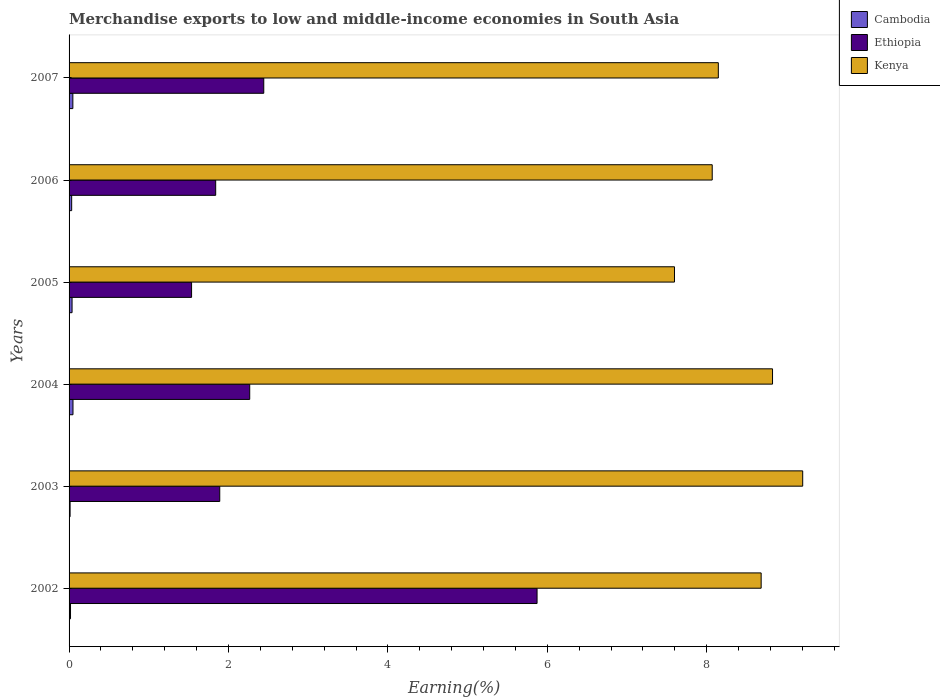How many different coloured bars are there?
Offer a terse response. 3. How many groups of bars are there?
Provide a short and direct response. 6. Are the number of bars per tick equal to the number of legend labels?
Provide a succinct answer. Yes. How many bars are there on the 5th tick from the top?
Keep it short and to the point. 3. What is the percentage of amount earned from merchandise exports in Ethiopia in 2004?
Your answer should be compact. 2.27. Across all years, what is the maximum percentage of amount earned from merchandise exports in Kenya?
Give a very brief answer. 9.2. Across all years, what is the minimum percentage of amount earned from merchandise exports in Ethiopia?
Give a very brief answer. 1.54. In which year was the percentage of amount earned from merchandise exports in Kenya maximum?
Make the answer very short. 2003. In which year was the percentage of amount earned from merchandise exports in Cambodia minimum?
Provide a succinct answer. 2003. What is the total percentage of amount earned from merchandise exports in Cambodia in the graph?
Keep it short and to the point. 0.2. What is the difference between the percentage of amount earned from merchandise exports in Kenya in 2002 and that in 2003?
Provide a short and direct response. -0.52. What is the difference between the percentage of amount earned from merchandise exports in Kenya in 2004 and the percentage of amount earned from merchandise exports in Cambodia in 2007?
Provide a short and direct response. 8.78. What is the average percentage of amount earned from merchandise exports in Cambodia per year?
Your answer should be very brief. 0.03. In the year 2003, what is the difference between the percentage of amount earned from merchandise exports in Ethiopia and percentage of amount earned from merchandise exports in Cambodia?
Provide a succinct answer. 1.88. What is the ratio of the percentage of amount earned from merchandise exports in Kenya in 2006 to that in 2007?
Your answer should be very brief. 0.99. Is the percentage of amount earned from merchandise exports in Ethiopia in 2003 less than that in 2004?
Give a very brief answer. Yes. What is the difference between the highest and the second highest percentage of amount earned from merchandise exports in Kenya?
Your response must be concise. 0.38. What is the difference between the highest and the lowest percentage of amount earned from merchandise exports in Kenya?
Give a very brief answer. 1.61. In how many years, is the percentage of amount earned from merchandise exports in Kenya greater than the average percentage of amount earned from merchandise exports in Kenya taken over all years?
Offer a terse response. 3. Is the sum of the percentage of amount earned from merchandise exports in Ethiopia in 2005 and 2006 greater than the maximum percentage of amount earned from merchandise exports in Kenya across all years?
Offer a very short reply. No. What does the 1st bar from the top in 2004 represents?
Ensure brevity in your answer.  Kenya. What does the 3rd bar from the bottom in 2005 represents?
Your response must be concise. Kenya. What is the difference between two consecutive major ticks on the X-axis?
Give a very brief answer. 2. Does the graph contain any zero values?
Give a very brief answer. No. Where does the legend appear in the graph?
Provide a short and direct response. Top right. What is the title of the graph?
Your answer should be very brief. Merchandise exports to low and middle-income economies in South Asia. What is the label or title of the X-axis?
Keep it short and to the point. Earning(%). What is the Earning(%) in Cambodia in 2002?
Ensure brevity in your answer.  0.02. What is the Earning(%) of Ethiopia in 2002?
Your response must be concise. 5.87. What is the Earning(%) in Kenya in 2002?
Provide a short and direct response. 8.68. What is the Earning(%) in Cambodia in 2003?
Keep it short and to the point. 0.01. What is the Earning(%) in Ethiopia in 2003?
Make the answer very short. 1.89. What is the Earning(%) in Kenya in 2003?
Give a very brief answer. 9.2. What is the Earning(%) of Cambodia in 2004?
Ensure brevity in your answer.  0.05. What is the Earning(%) of Ethiopia in 2004?
Provide a succinct answer. 2.27. What is the Earning(%) in Kenya in 2004?
Give a very brief answer. 8.83. What is the Earning(%) in Cambodia in 2005?
Provide a short and direct response. 0.04. What is the Earning(%) in Ethiopia in 2005?
Your answer should be very brief. 1.54. What is the Earning(%) in Kenya in 2005?
Ensure brevity in your answer.  7.6. What is the Earning(%) of Cambodia in 2006?
Keep it short and to the point. 0.03. What is the Earning(%) of Ethiopia in 2006?
Ensure brevity in your answer.  1.84. What is the Earning(%) in Kenya in 2006?
Keep it short and to the point. 8.07. What is the Earning(%) of Cambodia in 2007?
Keep it short and to the point. 0.05. What is the Earning(%) in Ethiopia in 2007?
Give a very brief answer. 2.44. What is the Earning(%) in Kenya in 2007?
Your answer should be very brief. 8.15. Across all years, what is the maximum Earning(%) of Cambodia?
Your answer should be compact. 0.05. Across all years, what is the maximum Earning(%) in Ethiopia?
Offer a terse response. 5.87. Across all years, what is the maximum Earning(%) in Kenya?
Ensure brevity in your answer.  9.2. Across all years, what is the minimum Earning(%) of Cambodia?
Provide a short and direct response. 0.01. Across all years, what is the minimum Earning(%) in Ethiopia?
Your response must be concise. 1.54. Across all years, what is the minimum Earning(%) of Kenya?
Keep it short and to the point. 7.6. What is the total Earning(%) of Cambodia in the graph?
Ensure brevity in your answer.  0.2. What is the total Earning(%) of Ethiopia in the graph?
Offer a terse response. 15.85. What is the total Earning(%) in Kenya in the graph?
Your response must be concise. 50.52. What is the difference between the Earning(%) in Cambodia in 2002 and that in 2003?
Your response must be concise. 0.01. What is the difference between the Earning(%) of Ethiopia in 2002 and that in 2003?
Provide a short and direct response. 3.98. What is the difference between the Earning(%) of Kenya in 2002 and that in 2003?
Ensure brevity in your answer.  -0.52. What is the difference between the Earning(%) of Cambodia in 2002 and that in 2004?
Your answer should be compact. -0.03. What is the difference between the Earning(%) of Ethiopia in 2002 and that in 2004?
Your response must be concise. 3.6. What is the difference between the Earning(%) of Kenya in 2002 and that in 2004?
Provide a succinct answer. -0.14. What is the difference between the Earning(%) in Cambodia in 2002 and that in 2005?
Keep it short and to the point. -0.02. What is the difference between the Earning(%) in Ethiopia in 2002 and that in 2005?
Keep it short and to the point. 4.33. What is the difference between the Earning(%) in Kenya in 2002 and that in 2005?
Offer a terse response. 1.09. What is the difference between the Earning(%) in Cambodia in 2002 and that in 2006?
Provide a short and direct response. -0.01. What is the difference between the Earning(%) of Ethiopia in 2002 and that in 2006?
Give a very brief answer. 4.03. What is the difference between the Earning(%) in Kenya in 2002 and that in 2006?
Provide a short and direct response. 0.61. What is the difference between the Earning(%) of Cambodia in 2002 and that in 2007?
Make the answer very short. -0.03. What is the difference between the Earning(%) in Ethiopia in 2002 and that in 2007?
Make the answer very short. 3.43. What is the difference between the Earning(%) in Kenya in 2002 and that in 2007?
Provide a short and direct response. 0.54. What is the difference between the Earning(%) in Cambodia in 2003 and that in 2004?
Provide a succinct answer. -0.04. What is the difference between the Earning(%) in Ethiopia in 2003 and that in 2004?
Your response must be concise. -0.38. What is the difference between the Earning(%) in Kenya in 2003 and that in 2004?
Give a very brief answer. 0.38. What is the difference between the Earning(%) in Cambodia in 2003 and that in 2005?
Provide a succinct answer. -0.02. What is the difference between the Earning(%) of Ethiopia in 2003 and that in 2005?
Keep it short and to the point. 0.35. What is the difference between the Earning(%) of Kenya in 2003 and that in 2005?
Your answer should be compact. 1.61. What is the difference between the Earning(%) in Cambodia in 2003 and that in 2006?
Provide a short and direct response. -0.02. What is the difference between the Earning(%) in Ethiopia in 2003 and that in 2006?
Your answer should be compact. 0.05. What is the difference between the Earning(%) in Kenya in 2003 and that in 2006?
Provide a succinct answer. 1.14. What is the difference between the Earning(%) of Cambodia in 2003 and that in 2007?
Ensure brevity in your answer.  -0.03. What is the difference between the Earning(%) in Ethiopia in 2003 and that in 2007?
Offer a very short reply. -0.55. What is the difference between the Earning(%) of Kenya in 2003 and that in 2007?
Offer a terse response. 1.06. What is the difference between the Earning(%) of Cambodia in 2004 and that in 2005?
Offer a very short reply. 0.01. What is the difference between the Earning(%) of Ethiopia in 2004 and that in 2005?
Your response must be concise. 0.73. What is the difference between the Earning(%) of Kenya in 2004 and that in 2005?
Ensure brevity in your answer.  1.23. What is the difference between the Earning(%) of Cambodia in 2004 and that in 2006?
Your response must be concise. 0.02. What is the difference between the Earning(%) of Ethiopia in 2004 and that in 2006?
Give a very brief answer. 0.43. What is the difference between the Earning(%) in Kenya in 2004 and that in 2006?
Offer a terse response. 0.76. What is the difference between the Earning(%) of Cambodia in 2004 and that in 2007?
Ensure brevity in your answer.  0. What is the difference between the Earning(%) of Ethiopia in 2004 and that in 2007?
Offer a terse response. -0.18. What is the difference between the Earning(%) of Kenya in 2004 and that in 2007?
Your answer should be compact. 0.68. What is the difference between the Earning(%) of Cambodia in 2005 and that in 2006?
Your response must be concise. 0. What is the difference between the Earning(%) of Ethiopia in 2005 and that in 2006?
Your answer should be compact. -0.3. What is the difference between the Earning(%) in Kenya in 2005 and that in 2006?
Your response must be concise. -0.47. What is the difference between the Earning(%) in Cambodia in 2005 and that in 2007?
Your response must be concise. -0.01. What is the difference between the Earning(%) in Ethiopia in 2005 and that in 2007?
Give a very brief answer. -0.91. What is the difference between the Earning(%) of Kenya in 2005 and that in 2007?
Keep it short and to the point. -0.55. What is the difference between the Earning(%) in Cambodia in 2006 and that in 2007?
Keep it short and to the point. -0.01. What is the difference between the Earning(%) of Ethiopia in 2006 and that in 2007?
Your answer should be compact. -0.6. What is the difference between the Earning(%) in Kenya in 2006 and that in 2007?
Offer a very short reply. -0.08. What is the difference between the Earning(%) in Cambodia in 2002 and the Earning(%) in Ethiopia in 2003?
Your response must be concise. -1.87. What is the difference between the Earning(%) in Cambodia in 2002 and the Earning(%) in Kenya in 2003?
Your answer should be compact. -9.19. What is the difference between the Earning(%) of Ethiopia in 2002 and the Earning(%) of Kenya in 2003?
Your answer should be compact. -3.33. What is the difference between the Earning(%) in Cambodia in 2002 and the Earning(%) in Ethiopia in 2004?
Offer a very short reply. -2.25. What is the difference between the Earning(%) in Cambodia in 2002 and the Earning(%) in Kenya in 2004?
Your response must be concise. -8.81. What is the difference between the Earning(%) in Ethiopia in 2002 and the Earning(%) in Kenya in 2004?
Make the answer very short. -2.95. What is the difference between the Earning(%) in Cambodia in 2002 and the Earning(%) in Ethiopia in 2005?
Offer a terse response. -1.52. What is the difference between the Earning(%) of Cambodia in 2002 and the Earning(%) of Kenya in 2005?
Ensure brevity in your answer.  -7.58. What is the difference between the Earning(%) in Ethiopia in 2002 and the Earning(%) in Kenya in 2005?
Your answer should be very brief. -1.72. What is the difference between the Earning(%) in Cambodia in 2002 and the Earning(%) in Ethiopia in 2006?
Your answer should be very brief. -1.82. What is the difference between the Earning(%) of Cambodia in 2002 and the Earning(%) of Kenya in 2006?
Provide a succinct answer. -8.05. What is the difference between the Earning(%) of Ethiopia in 2002 and the Earning(%) of Kenya in 2006?
Provide a short and direct response. -2.2. What is the difference between the Earning(%) of Cambodia in 2002 and the Earning(%) of Ethiopia in 2007?
Your answer should be compact. -2.42. What is the difference between the Earning(%) in Cambodia in 2002 and the Earning(%) in Kenya in 2007?
Provide a succinct answer. -8.13. What is the difference between the Earning(%) of Ethiopia in 2002 and the Earning(%) of Kenya in 2007?
Keep it short and to the point. -2.27. What is the difference between the Earning(%) in Cambodia in 2003 and the Earning(%) in Ethiopia in 2004?
Provide a short and direct response. -2.25. What is the difference between the Earning(%) of Cambodia in 2003 and the Earning(%) of Kenya in 2004?
Make the answer very short. -8.81. What is the difference between the Earning(%) in Ethiopia in 2003 and the Earning(%) in Kenya in 2004?
Make the answer very short. -6.93. What is the difference between the Earning(%) of Cambodia in 2003 and the Earning(%) of Ethiopia in 2005?
Your answer should be very brief. -1.52. What is the difference between the Earning(%) in Cambodia in 2003 and the Earning(%) in Kenya in 2005?
Ensure brevity in your answer.  -7.58. What is the difference between the Earning(%) in Ethiopia in 2003 and the Earning(%) in Kenya in 2005?
Your answer should be very brief. -5.7. What is the difference between the Earning(%) of Cambodia in 2003 and the Earning(%) of Ethiopia in 2006?
Your response must be concise. -1.83. What is the difference between the Earning(%) in Cambodia in 2003 and the Earning(%) in Kenya in 2006?
Make the answer very short. -8.06. What is the difference between the Earning(%) of Ethiopia in 2003 and the Earning(%) of Kenya in 2006?
Provide a succinct answer. -6.18. What is the difference between the Earning(%) in Cambodia in 2003 and the Earning(%) in Ethiopia in 2007?
Make the answer very short. -2.43. What is the difference between the Earning(%) in Cambodia in 2003 and the Earning(%) in Kenya in 2007?
Keep it short and to the point. -8.13. What is the difference between the Earning(%) in Ethiopia in 2003 and the Earning(%) in Kenya in 2007?
Provide a succinct answer. -6.26. What is the difference between the Earning(%) in Cambodia in 2004 and the Earning(%) in Ethiopia in 2005?
Ensure brevity in your answer.  -1.49. What is the difference between the Earning(%) in Cambodia in 2004 and the Earning(%) in Kenya in 2005?
Offer a terse response. -7.55. What is the difference between the Earning(%) of Ethiopia in 2004 and the Earning(%) of Kenya in 2005?
Offer a terse response. -5.33. What is the difference between the Earning(%) of Cambodia in 2004 and the Earning(%) of Ethiopia in 2006?
Your answer should be very brief. -1.79. What is the difference between the Earning(%) of Cambodia in 2004 and the Earning(%) of Kenya in 2006?
Provide a short and direct response. -8.02. What is the difference between the Earning(%) of Ethiopia in 2004 and the Earning(%) of Kenya in 2006?
Your answer should be very brief. -5.8. What is the difference between the Earning(%) of Cambodia in 2004 and the Earning(%) of Ethiopia in 2007?
Keep it short and to the point. -2.39. What is the difference between the Earning(%) in Cambodia in 2004 and the Earning(%) in Kenya in 2007?
Ensure brevity in your answer.  -8.1. What is the difference between the Earning(%) in Ethiopia in 2004 and the Earning(%) in Kenya in 2007?
Offer a terse response. -5.88. What is the difference between the Earning(%) of Cambodia in 2005 and the Earning(%) of Ethiopia in 2006?
Keep it short and to the point. -1.8. What is the difference between the Earning(%) of Cambodia in 2005 and the Earning(%) of Kenya in 2006?
Your response must be concise. -8.03. What is the difference between the Earning(%) of Ethiopia in 2005 and the Earning(%) of Kenya in 2006?
Your answer should be compact. -6.53. What is the difference between the Earning(%) in Cambodia in 2005 and the Earning(%) in Ethiopia in 2007?
Keep it short and to the point. -2.4. What is the difference between the Earning(%) of Cambodia in 2005 and the Earning(%) of Kenya in 2007?
Offer a terse response. -8.11. What is the difference between the Earning(%) in Ethiopia in 2005 and the Earning(%) in Kenya in 2007?
Keep it short and to the point. -6.61. What is the difference between the Earning(%) in Cambodia in 2006 and the Earning(%) in Ethiopia in 2007?
Keep it short and to the point. -2.41. What is the difference between the Earning(%) of Cambodia in 2006 and the Earning(%) of Kenya in 2007?
Ensure brevity in your answer.  -8.11. What is the difference between the Earning(%) of Ethiopia in 2006 and the Earning(%) of Kenya in 2007?
Your answer should be very brief. -6.31. What is the average Earning(%) of Cambodia per year?
Offer a very short reply. 0.03. What is the average Earning(%) in Ethiopia per year?
Offer a very short reply. 2.64. What is the average Earning(%) of Kenya per year?
Keep it short and to the point. 8.42. In the year 2002, what is the difference between the Earning(%) of Cambodia and Earning(%) of Ethiopia?
Make the answer very short. -5.85. In the year 2002, what is the difference between the Earning(%) in Cambodia and Earning(%) in Kenya?
Provide a succinct answer. -8.66. In the year 2002, what is the difference between the Earning(%) in Ethiopia and Earning(%) in Kenya?
Offer a very short reply. -2.81. In the year 2003, what is the difference between the Earning(%) in Cambodia and Earning(%) in Ethiopia?
Give a very brief answer. -1.88. In the year 2003, what is the difference between the Earning(%) in Cambodia and Earning(%) in Kenya?
Make the answer very short. -9.19. In the year 2003, what is the difference between the Earning(%) in Ethiopia and Earning(%) in Kenya?
Ensure brevity in your answer.  -7.31. In the year 2004, what is the difference between the Earning(%) in Cambodia and Earning(%) in Ethiopia?
Offer a very short reply. -2.22. In the year 2004, what is the difference between the Earning(%) of Cambodia and Earning(%) of Kenya?
Give a very brief answer. -8.78. In the year 2004, what is the difference between the Earning(%) in Ethiopia and Earning(%) in Kenya?
Keep it short and to the point. -6.56. In the year 2005, what is the difference between the Earning(%) of Cambodia and Earning(%) of Ethiopia?
Your answer should be very brief. -1.5. In the year 2005, what is the difference between the Earning(%) of Cambodia and Earning(%) of Kenya?
Your answer should be compact. -7.56. In the year 2005, what is the difference between the Earning(%) in Ethiopia and Earning(%) in Kenya?
Provide a short and direct response. -6.06. In the year 2006, what is the difference between the Earning(%) of Cambodia and Earning(%) of Ethiopia?
Provide a succinct answer. -1.81. In the year 2006, what is the difference between the Earning(%) in Cambodia and Earning(%) in Kenya?
Ensure brevity in your answer.  -8.04. In the year 2006, what is the difference between the Earning(%) of Ethiopia and Earning(%) of Kenya?
Your response must be concise. -6.23. In the year 2007, what is the difference between the Earning(%) in Cambodia and Earning(%) in Ethiopia?
Your answer should be very brief. -2.4. In the year 2007, what is the difference between the Earning(%) of Cambodia and Earning(%) of Kenya?
Make the answer very short. -8.1. In the year 2007, what is the difference between the Earning(%) of Ethiopia and Earning(%) of Kenya?
Make the answer very short. -5.7. What is the ratio of the Earning(%) in Cambodia in 2002 to that in 2003?
Your answer should be compact. 1.41. What is the ratio of the Earning(%) in Ethiopia in 2002 to that in 2003?
Ensure brevity in your answer.  3.11. What is the ratio of the Earning(%) in Kenya in 2002 to that in 2003?
Offer a terse response. 0.94. What is the ratio of the Earning(%) in Cambodia in 2002 to that in 2004?
Keep it short and to the point. 0.37. What is the ratio of the Earning(%) of Ethiopia in 2002 to that in 2004?
Provide a succinct answer. 2.59. What is the ratio of the Earning(%) in Kenya in 2002 to that in 2004?
Provide a succinct answer. 0.98. What is the ratio of the Earning(%) in Cambodia in 2002 to that in 2005?
Your response must be concise. 0.48. What is the ratio of the Earning(%) of Ethiopia in 2002 to that in 2005?
Give a very brief answer. 3.82. What is the ratio of the Earning(%) of Kenya in 2002 to that in 2005?
Provide a short and direct response. 1.14. What is the ratio of the Earning(%) in Cambodia in 2002 to that in 2006?
Provide a short and direct response. 0.56. What is the ratio of the Earning(%) in Ethiopia in 2002 to that in 2006?
Your response must be concise. 3.19. What is the ratio of the Earning(%) of Kenya in 2002 to that in 2006?
Ensure brevity in your answer.  1.08. What is the ratio of the Earning(%) in Cambodia in 2002 to that in 2007?
Your response must be concise. 0.38. What is the ratio of the Earning(%) in Ethiopia in 2002 to that in 2007?
Your answer should be compact. 2.4. What is the ratio of the Earning(%) of Kenya in 2002 to that in 2007?
Ensure brevity in your answer.  1.07. What is the ratio of the Earning(%) of Cambodia in 2003 to that in 2004?
Provide a short and direct response. 0.26. What is the ratio of the Earning(%) of Ethiopia in 2003 to that in 2004?
Provide a short and direct response. 0.83. What is the ratio of the Earning(%) in Kenya in 2003 to that in 2004?
Make the answer very short. 1.04. What is the ratio of the Earning(%) of Cambodia in 2003 to that in 2005?
Your answer should be very brief. 0.34. What is the ratio of the Earning(%) of Ethiopia in 2003 to that in 2005?
Provide a succinct answer. 1.23. What is the ratio of the Earning(%) of Kenya in 2003 to that in 2005?
Offer a very short reply. 1.21. What is the ratio of the Earning(%) in Cambodia in 2003 to that in 2006?
Ensure brevity in your answer.  0.4. What is the ratio of the Earning(%) in Ethiopia in 2003 to that in 2006?
Give a very brief answer. 1.03. What is the ratio of the Earning(%) in Kenya in 2003 to that in 2006?
Your answer should be very brief. 1.14. What is the ratio of the Earning(%) of Cambodia in 2003 to that in 2007?
Your answer should be compact. 0.27. What is the ratio of the Earning(%) in Ethiopia in 2003 to that in 2007?
Provide a short and direct response. 0.77. What is the ratio of the Earning(%) in Kenya in 2003 to that in 2007?
Provide a short and direct response. 1.13. What is the ratio of the Earning(%) in Cambodia in 2004 to that in 2005?
Ensure brevity in your answer.  1.31. What is the ratio of the Earning(%) in Ethiopia in 2004 to that in 2005?
Your response must be concise. 1.47. What is the ratio of the Earning(%) in Kenya in 2004 to that in 2005?
Your response must be concise. 1.16. What is the ratio of the Earning(%) of Cambodia in 2004 to that in 2006?
Your answer should be very brief. 1.5. What is the ratio of the Earning(%) in Ethiopia in 2004 to that in 2006?
Give a very brief answer. 1.23. What is the ratio of the Earning(%) in Kenya in 2004 to that in 2006?
Offer a terse response. 1.09. What is the ratio of the Earning(%) in Cambodia in 2004 to that in 2007?
Provide a short and direct response. 1.03. What is the ratio of the Earning(%) in Ethiopia in 2004 to that in 2007?
Make the answer very short. 0.93. What is the ratio of the Earning(%) of Kenya in 2004 to that in 2007?
Make the answer very short. 1.08. What is the ratio of the Earning(%) of Cambodia in 2005 to that in 2006?
Offer a terse response. 1.15. What is the ratio of the Earning(%) in Ethiopia in 2005 to that in 2006?
Keep it short and to the point. 0.84. What is the ratio of the Earning(%) in Kenya in 2005 to that in 2006?
Offer a terse response. 0.94. What is the ratio of the Earning(%) of Cambodia in 2005 to that in 2007?
Offer a terse response. 0.79. What is the ratio of the Earning(%) in Ethiopia in 2005 to that in 2007?
Keep it short and to the point. 0.63. What is the ratio of the Earning(%) of Kenya in 2005 to that in 2007?
Provide a succinct answer. 0.93. What is the ratio of the Earning(%) in Cambodia in 2006 to that in 2007?
Offer a terse response. 0.69. What is the ratio of the Earning(%) of Ethiopia in 2006 to that in 2007?
Give a very brief answer. 0.75. What is the ratio of the Earning(%) of Kenya in 2006 to that in 2007?
Your answer should be very brief. 0.99. What is the difference between the highest and the second highest Earning(%) of Cambodia?
Make the answer very short. 0. What is the difference between the highest and the second highest Earning(%) of Ethiopia?
Your response must be concise. 3.43. What is the difference between the highest and the second highest Earning(%) in Kenya?
Your response must be concise. 0.38. What is the difference between the highest and the lowest Earning(%) in Cambodia?
Ensure brevity in your answer.  0.04. What is the difference between the highest and the lowest Earning(%) in Ethiopia?
Your answer should be very brief. 4.33. What is the difference between the highest and the lowest Earning(%) of Kenya?
Give a very brief answer. 1.61. 